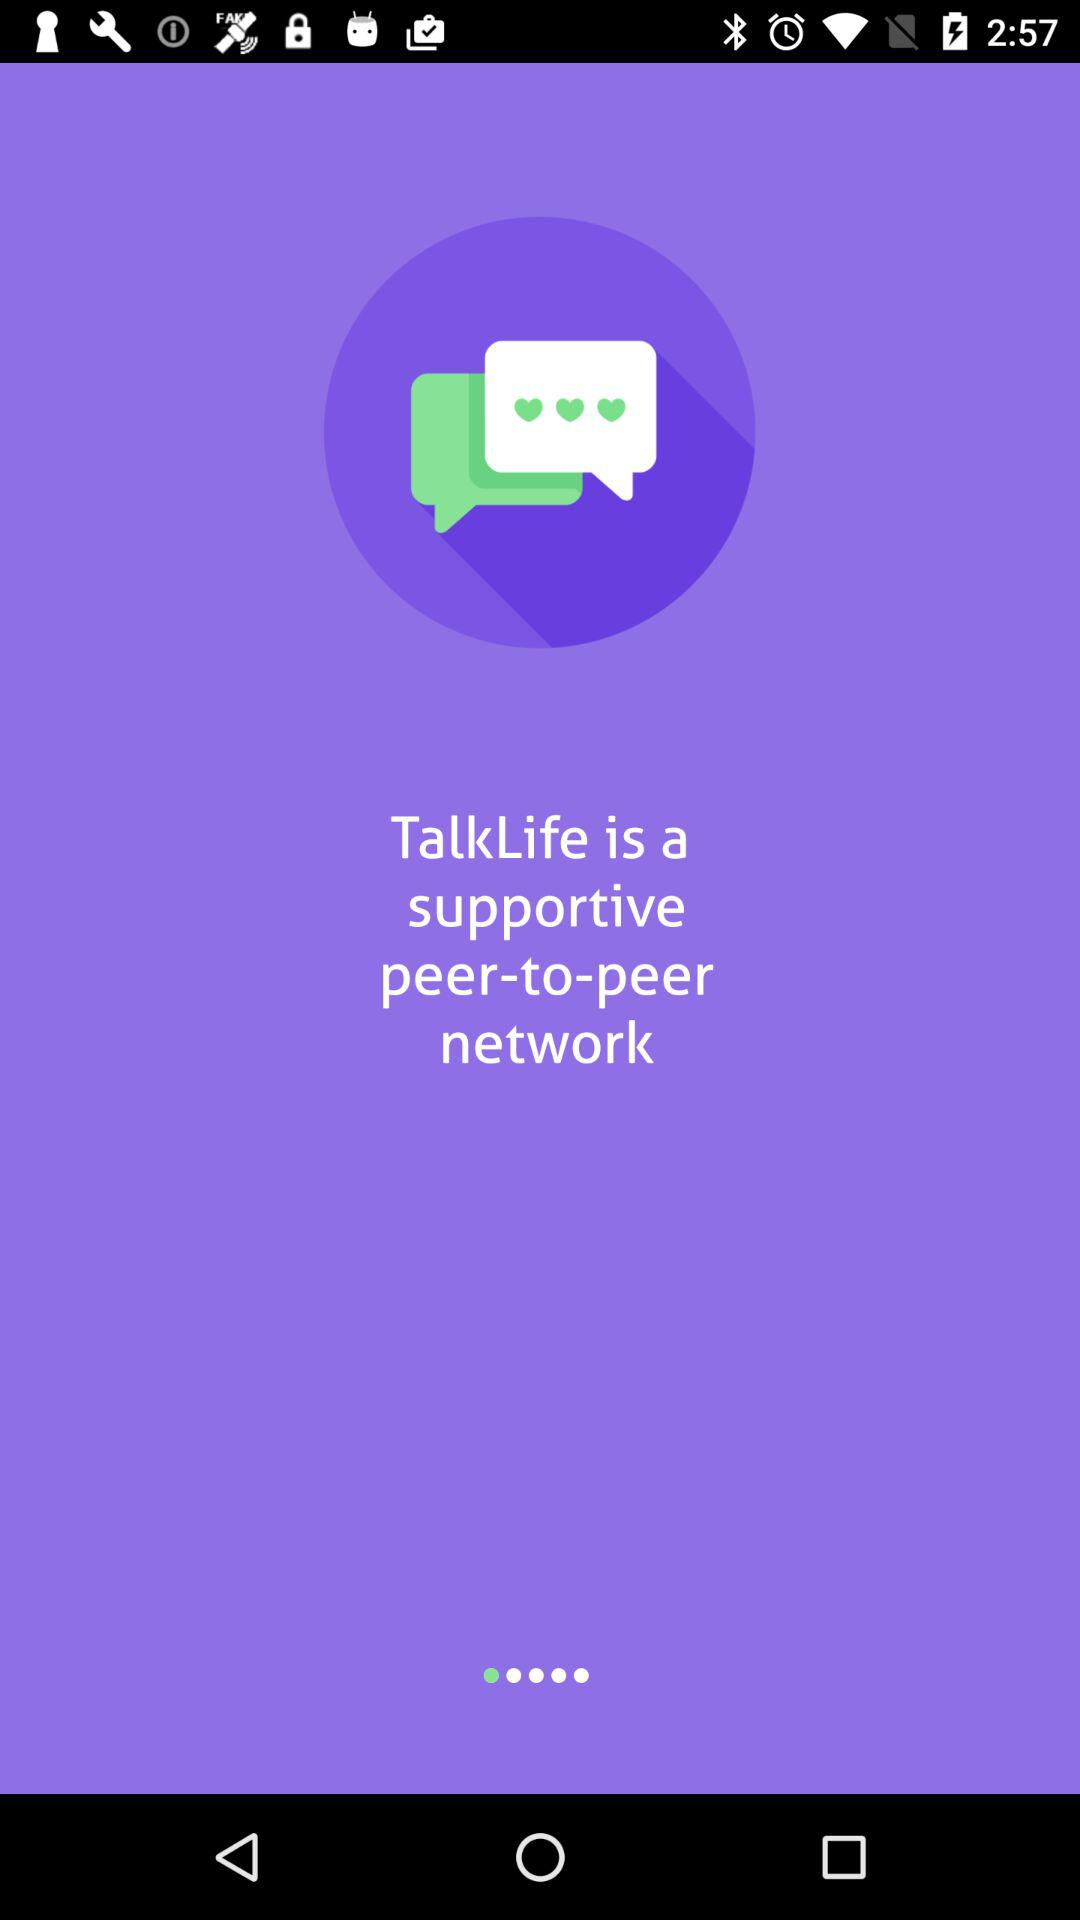What is "TalkLife"? It is a supportive peer-to-peer network. 